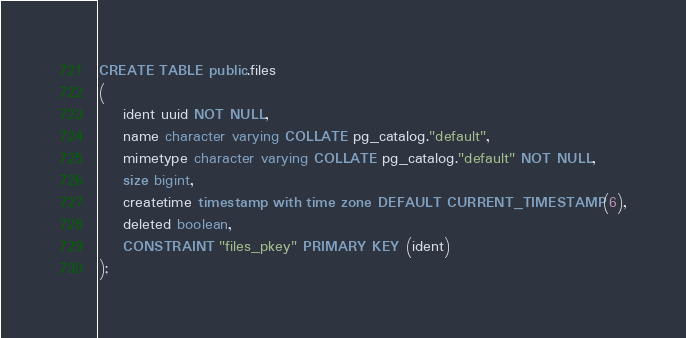<code> <loc_0><loc_0><loc_500><loc_500><_SQL_>CREATE TABLE public.files
(
    ident uuid NOT NULL,
    name character varying COLLATE pg_catalog."default",
    mimetype character varying COLLATE pg_catalog."default" NOT NULL,
    size bigint,
    createtime timestamp with time zone DEFAULT CURRENT_TIMESTAMP(6),
    deleted boolean,
    CONSTRAINT "files_pkey" PRIMARY KEY (ident)
);</code> 